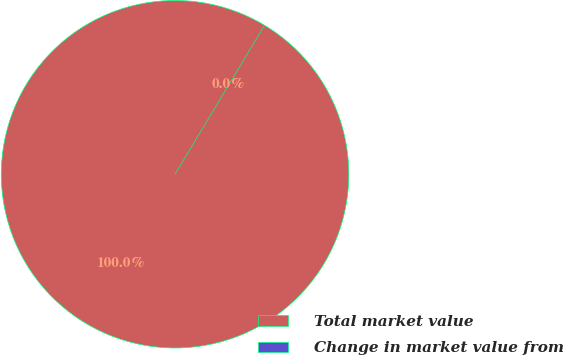<chart> <loc_0><loc_0><loc_500><loc_500><pie_chart><fcel>Total market value<fcel>Change in market value from<nl><fcel>100.0%<fcel>0.0%<nl></chart> 